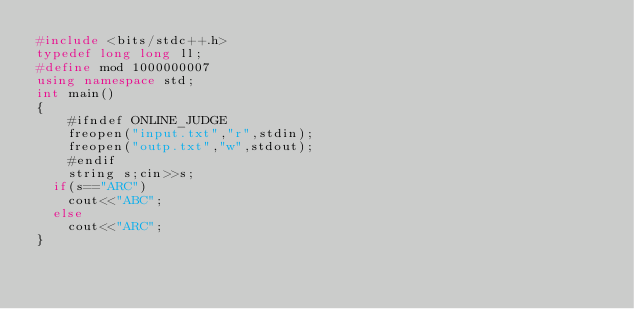Convert code to text. <code><loc_0><loc_0><loc_500><loc_500><_C++_>#include <bits/stdc++.h>
typedef long long ll;
#define mod 1000000007
using namespace std;
int main()
{
    #ifndef ONLINE_JUDGE
    freopen("input.txt","r",stdin);
    freopen("outp.txt","w",stdout);
    #endif
    string s;cin>>s;
  if(s=="ARC")
    cout<<"ABC";
  else
    cout<<"ARC";
}

    
</code> 